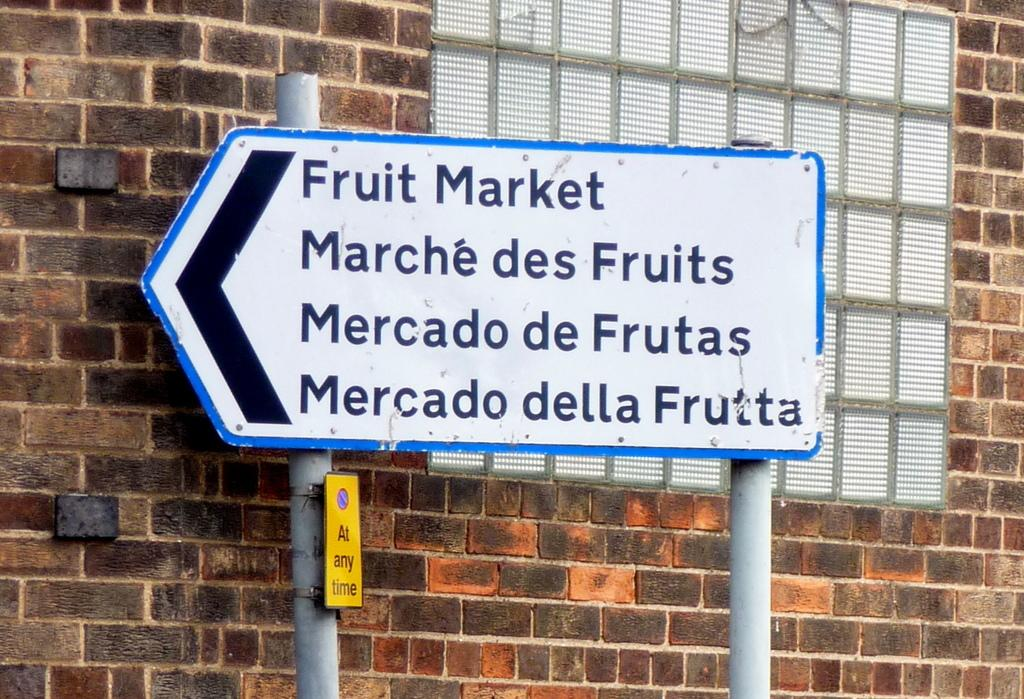<image>
Create a compact narrative representing the image presented. A sign pointing to a Fruit Market written in several languages. 